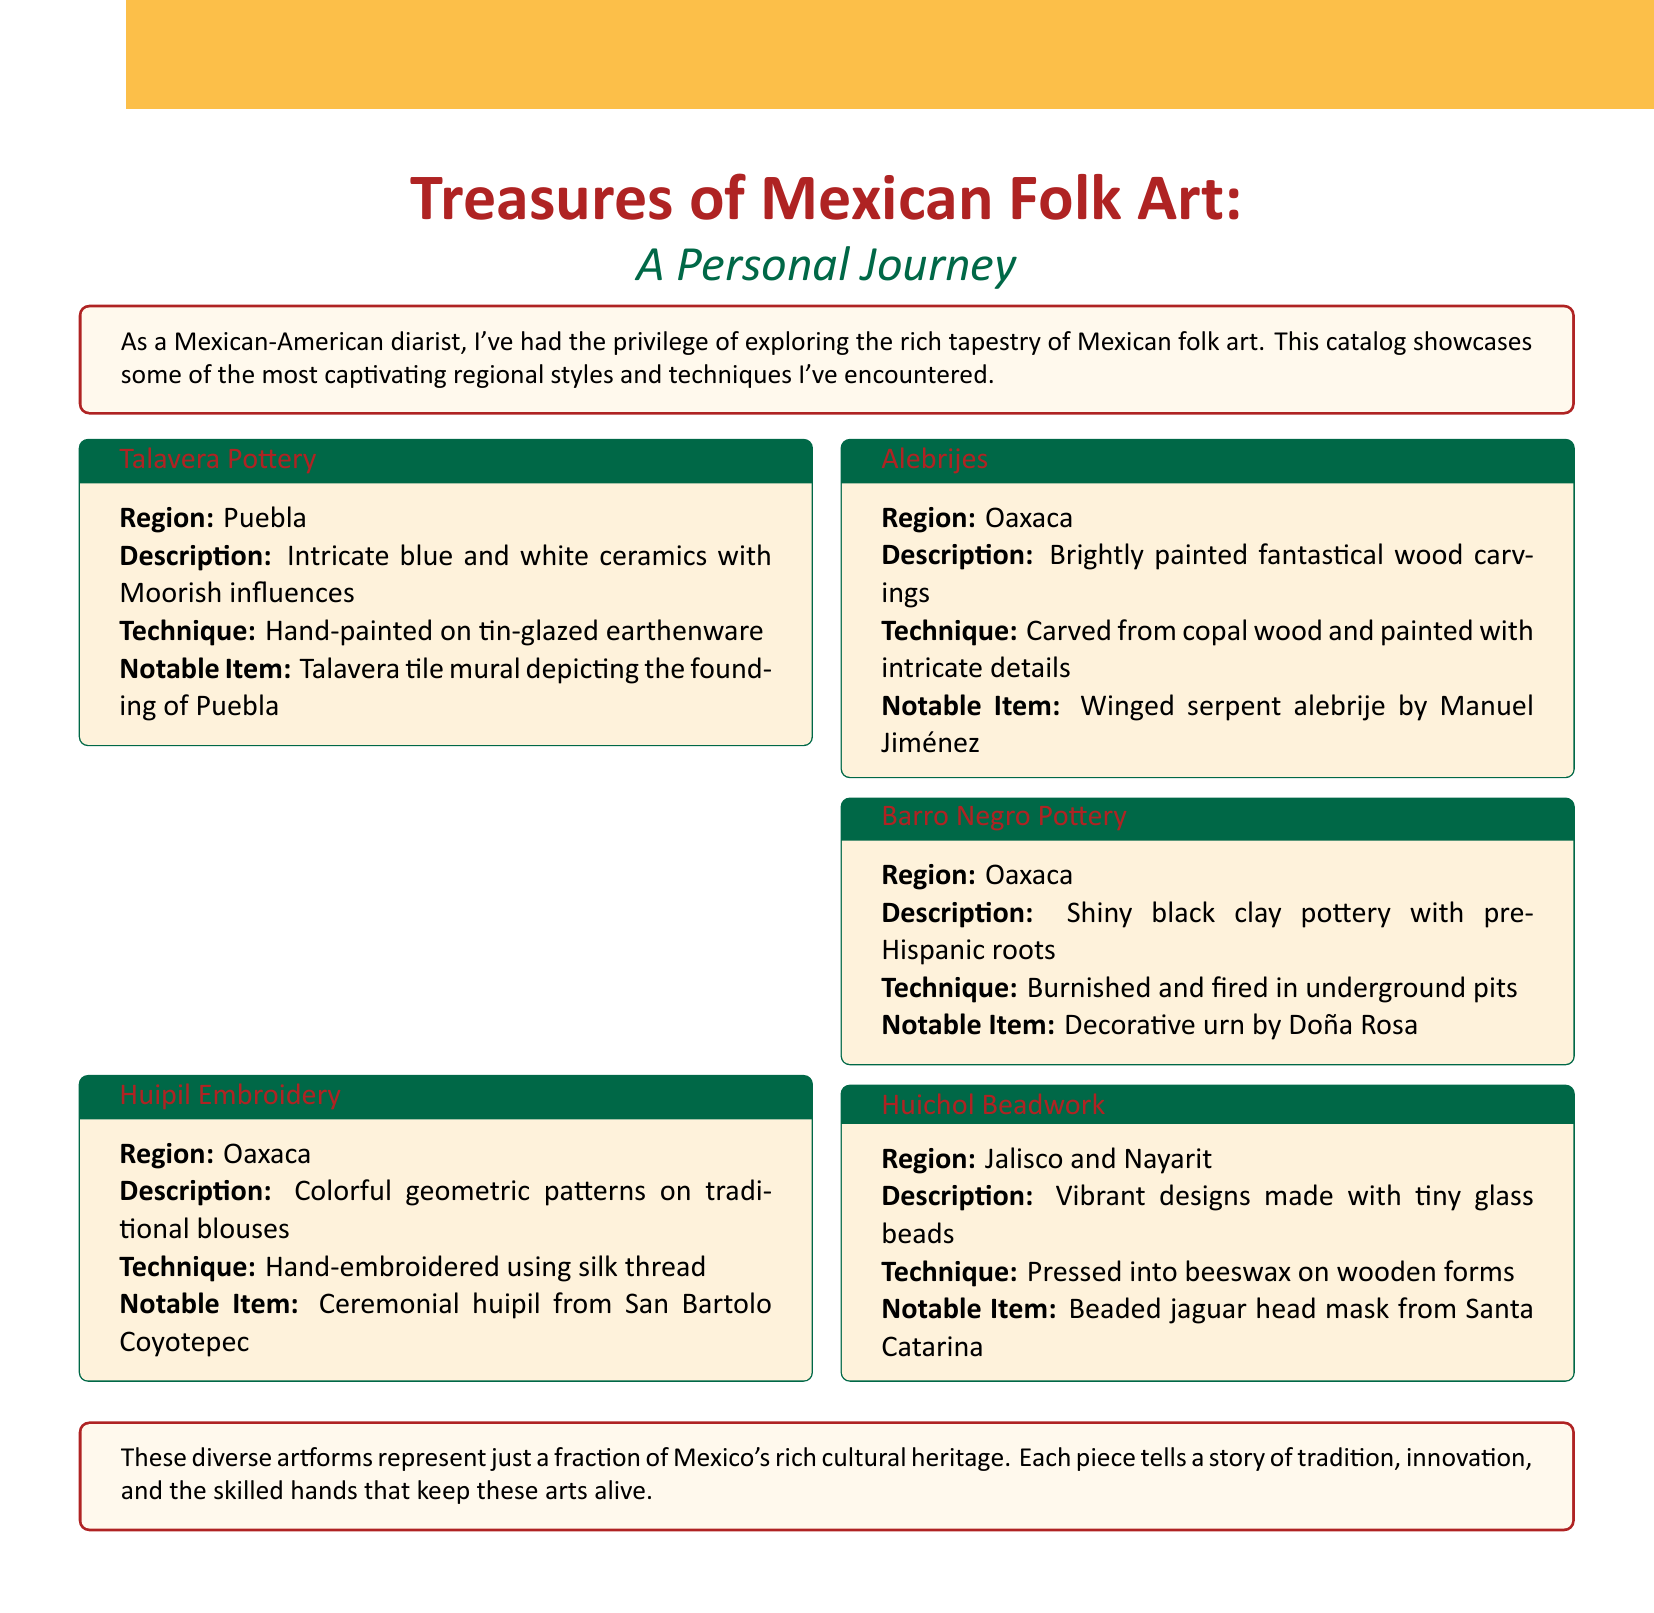What is the notable item of Talavera Pottery? The notable item listed under Talavera Pottery is a tile mural depicting the founding of Puebla.
Answer: Talavera tile mural depicting the founding of Puebla Which region is known for Alebrijes? The document specifies that Alebrijes come from Oaxaca.
Answer: Oaxaca What technique is used for Huipil Embroidery? Huipil Embroidery is hand-embroidered using silk thread.
Answer: Hand-embroidered using silk thread What is a characteristic of Barro Negro Pottery? Barro Negro Pottery is described as shiny black clay pottery with pre-Hispanic roots.
Answer: Shiny black clay pottery with pre-Hispanic roots What types of materials are used in Huichol Beadwork? Huichol Beadwork is made with tiny glass beads and beeswax.
Answer: Tiny glass beads What is the color of the background in the document? The document features a yellow background.
Answer: Yellow Which region is associated with Barro Negro Pottery? The document highlights that Barro Negro Pottery originates from Oaxaca.
Answer: Oaxaca What decorative item is featured in Huichol Beadwork? The notable item of Huichol Beadwork includes a beaded jaguar head mask.
Answer: Beaded jaguar head mask from Santa Catarina 